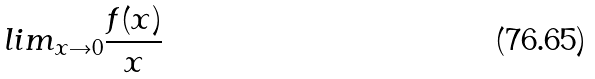<formula> <loc_0><loc_0><loc_500><loc_500>l i m _ { x \rightarrow 0 } \frac { f ( x ) } { x }</formula> 